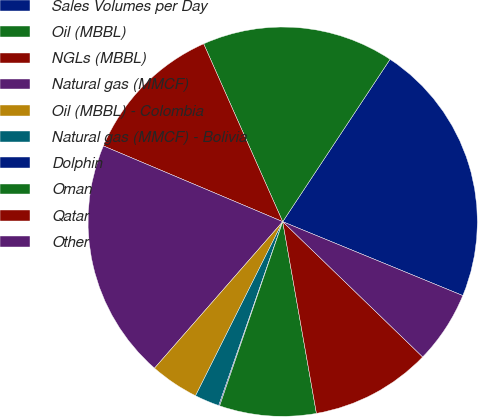Convert chart to OTSL. <chart><loc_0><loc_0><loc_500><loc_500><pie_chart><fcel>Sales Volumes per Day<fcel>Oil (MBBL)<fcel>NGLs (MBBL)<fcel>Natural gas (MMCF)<fcel>Oil (MBBL) - Colombia<fcel>Natural gas (MMCF) - Bolivia<fcel>Dolphin<fcel>Oman<fcel>Qatar<fcel>Other<nl><fcel>21.9%<fcel>15.95%<fcel>11.98%<fcel>19.92%<fcel>4.05%<fcel>2.06%<fcel>0.08%<fcel>8.02%<fcel>10.0%<fcel>6.03%<nl></chart> 